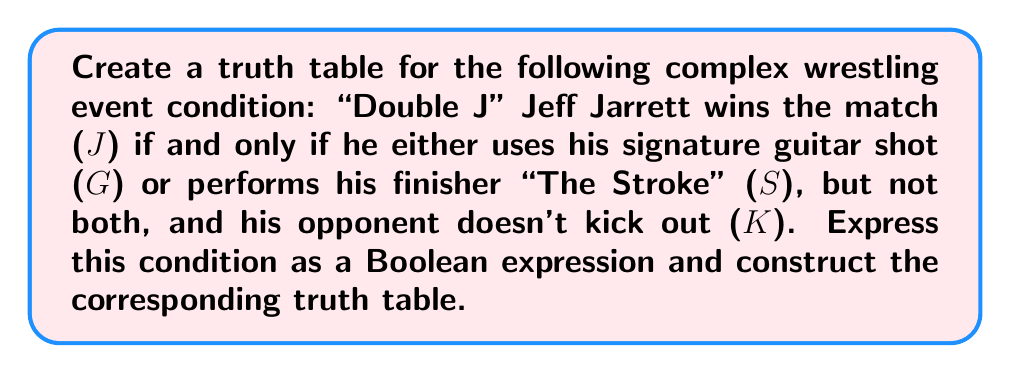What is the answer to this math problem? Let's approach this step-by-step:

1) First, we need to translate the given condition into a Boolean expression. The key phrase "if and only if" suggests a biconditional (↔) operation. The condition can be expressed as:

   $J \leftrightarrow ((G \oplus S) \land \lnot K)$

   Where $\oplus$ represents XOR (exclusive or).

2) Now, let's break down the components:
   - $G \oplus S$: Jarrett uses either the guitar shot or "The Stroke", but not both
   - $\lnot K$: The opponent doesn't kick out
   - $(G \oplus S) \land \lnot K$: The combined condition for Jarrett's victory

3) To create the truth table, we need to consider all possible combinations of the input variables G, S, and K. There are $2^3 = 8$ possible combinations.

4) Let's construct the truth table:

   | G | S | K | $G \oplus S$ | $\lnot K$ | $(G \oplus S) \land \lnot K$ | J |
   |---|---|---|--------------|-----------|------------------------------|---|
   | 0 | 0 | 0 | 0            | 1         | 0                            | 0 |
   | 0 | 0 | 1 | 0            | 0         | 0                            | 1 |
   | 0 | 1 | 0 | 1            | 1         | 1                            | 1 |
   | 0 | 1 | 1 | 1            | 0         | 0                            | 1 |
   | 1 | 0 | 0 | 1            | 1         | 1                            | 1 |
   | 1 | 0 | 1 | 1            | 0         | 0                            | 1 |
   | 1 | 1 | 0 | 0            | 1         | 0                            | 0 |
   | 1 | 1 | 1 | 0            | 0         | 0                            | 1 |

5) The final column J is determined by whether it matches the result of $(G \oplus S) \land \lnot K$. If they're the same, J is 1; if different, J is 0.

This truth table represents all possible outcomes of the match based on the given conditions.
Answer: $$
\begin{array}{|c|c|c|c|c|c|c|}
\hline
G & S & K & G \oplus S & \lnot K & (G \oplus S) \land \lnot K & J \\
\hline
0 & 0 & 0 & 0 & 1 & 0 & 0 \\
0 & 0 & 1 & 0 & 0 & 0 & 1 \\
0 & 1 & 0 & 1 & 1 & 1 & 1 \\
0 & 1 & 1 & 1 & 0 & 0 & 1 \\
1 & 0 & 0 & 1 & 1 & 1 & 1 \\
1 & 0 & 1 & 1 & 0 & 0 & 1 \\
1 & 1 & 0 & 0 & 1 & 0 & 0 \\
1 & 1 & 1 & 0 & 0 & 0 & 1 \\
\hline
\end{array}
$$ 